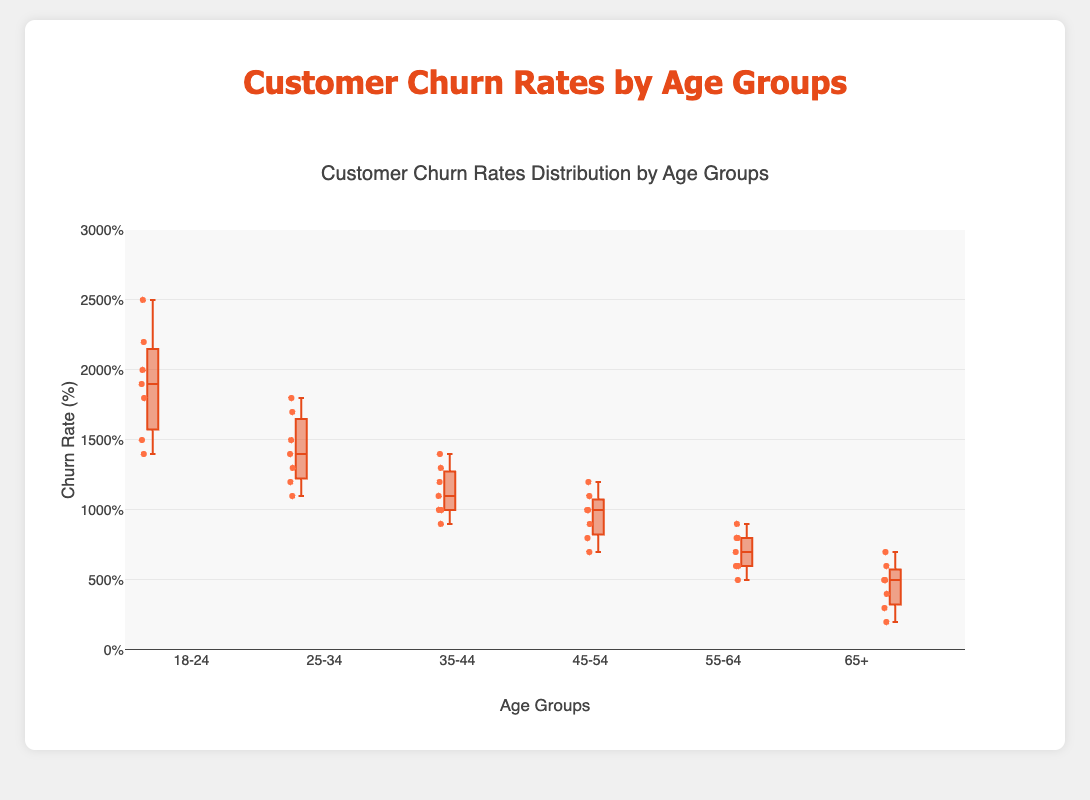What's the median churn rate for the age group 18-24? The median is the middle value when the data points are ordered from least to greatest. For 18-24, the data points are 14, 15, 18, 19, 20, 22, 25, so the median is 19.
Answer: 19 Which age group has the lowest median churn rate? By comparing the median values of all age groups, the group 65+ has the lowest median churn rate.
Answer: 65+ Among the age groups, which has the highest maximum churn rate? The maximum churn rate for each group can be identified from the upper whisks or data points beyond the whiskers. The 18-24 age group has the highest maximum churn rate of 25.
Answer: 18-24 What is the range of churn rates for the age group 55-64? The range is the difference between the maximum and minimum churn rates. For 55-64, the maximum is 9 and the minimum is 5, so the range is 9 - 5 = 4.
Answer: 4 Which age group shows the highest interquartile range (IQR)? The IQR is the difference between the 75th percentile (upper quartile) and the 25th percentile (lower quartile). The group 18-24 has the widest box indicating the highest IQR.
Answer: 18-24 What is the minimum churn rate for customers aged 45-54? The minimum churn rate for this group is represented by the bottom whisker or data point and is 7.
Answer: 7 For the age group 35-44, what are the first and third quartiles? The first quartile (Q1) and the third quartile (Q3) are the edges of the box. For 35-44, Q1 is around 10 and Q3 is around 13.
Answer: Q1: 10, Q3: 13 Which age group has the smallest range of churn rates? The range is the difference between the highest and lowest values. The age group 65+ has the smallest range as their churn rates vary from 2 to 7, giving a range of 5.
Answer: 65+ Compare the median churn rate between the age groups 25-34 and 55-64. Which one is higher? The median churn rate for 25-34 is higher than that of 55-64. 14 vs 7 respectively.
Answer: 25-34 